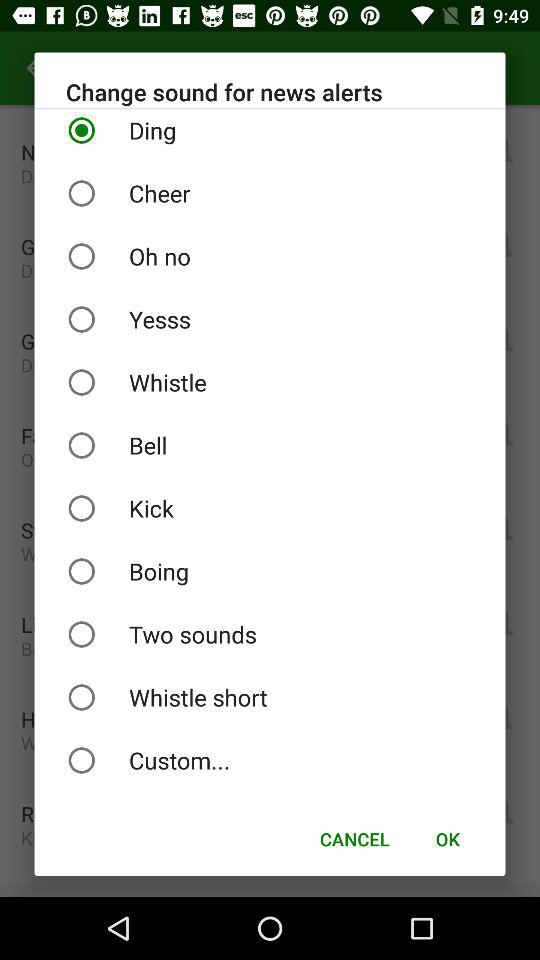What is the name of the application?
When the provided information is insufficient, respond with <no answer>. <no answer> 